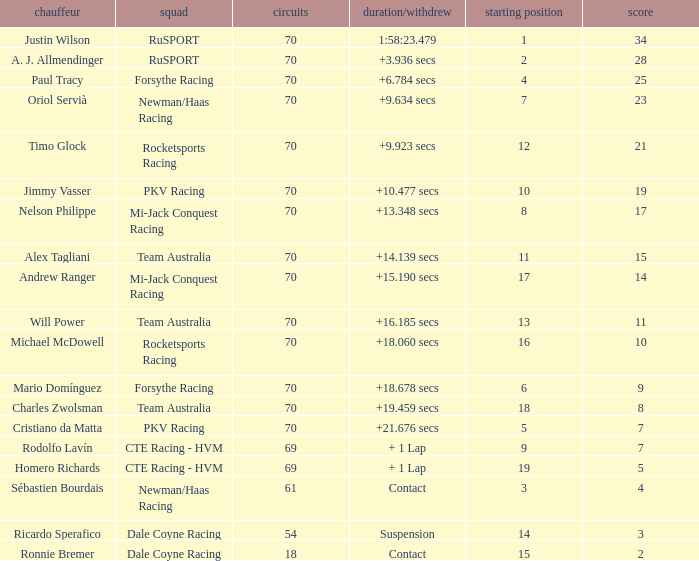Who scored with a grid of 10 and the highest amount of laps? 70.0. 